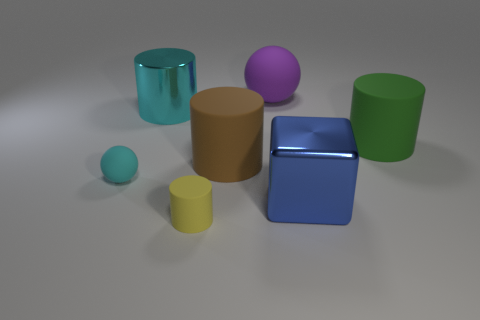Are there the same number of blue metal things left of the blue block and yellow matte spheres?
Ensure brevity in your answer.  Yes. Is there anything else that is the same material as the tiny ball?
Your answer should be compact. Yes. What number of small things are gray balls or purple spheres?
Ensure brevity in your answer.  0. There is a big metal thing that is the same color as the small sphere; what shape is it?
Give a very brief answer. Cylinder. Does the small thing that is on the right side of the big shiny cylinder have the same material as the large ball?
Ensure brevity in your answer.  Yes. Are there an equal number of tiny matte spheres and brown metal cubes?
Offer a terse response. No. There is a tiny thing that is right of the matte ball that is on the left side of the yellow matte object; what is its material?
Offer a very short reply. Rubber. How many big cyan metallic things have the same shape as the blue thing?
Make the answer very short. 0. How big is the rubber sphere that is behind the big cylinder in front of the large matte thing to the right of the big purple sphere?
Your response must be concise. Large. What number of red objects are either spheres or rubber things?
Make the answer very short. 0. 